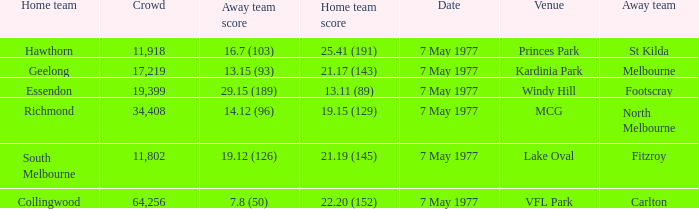Name the venue with a home team of geelong Kardinia Park. 